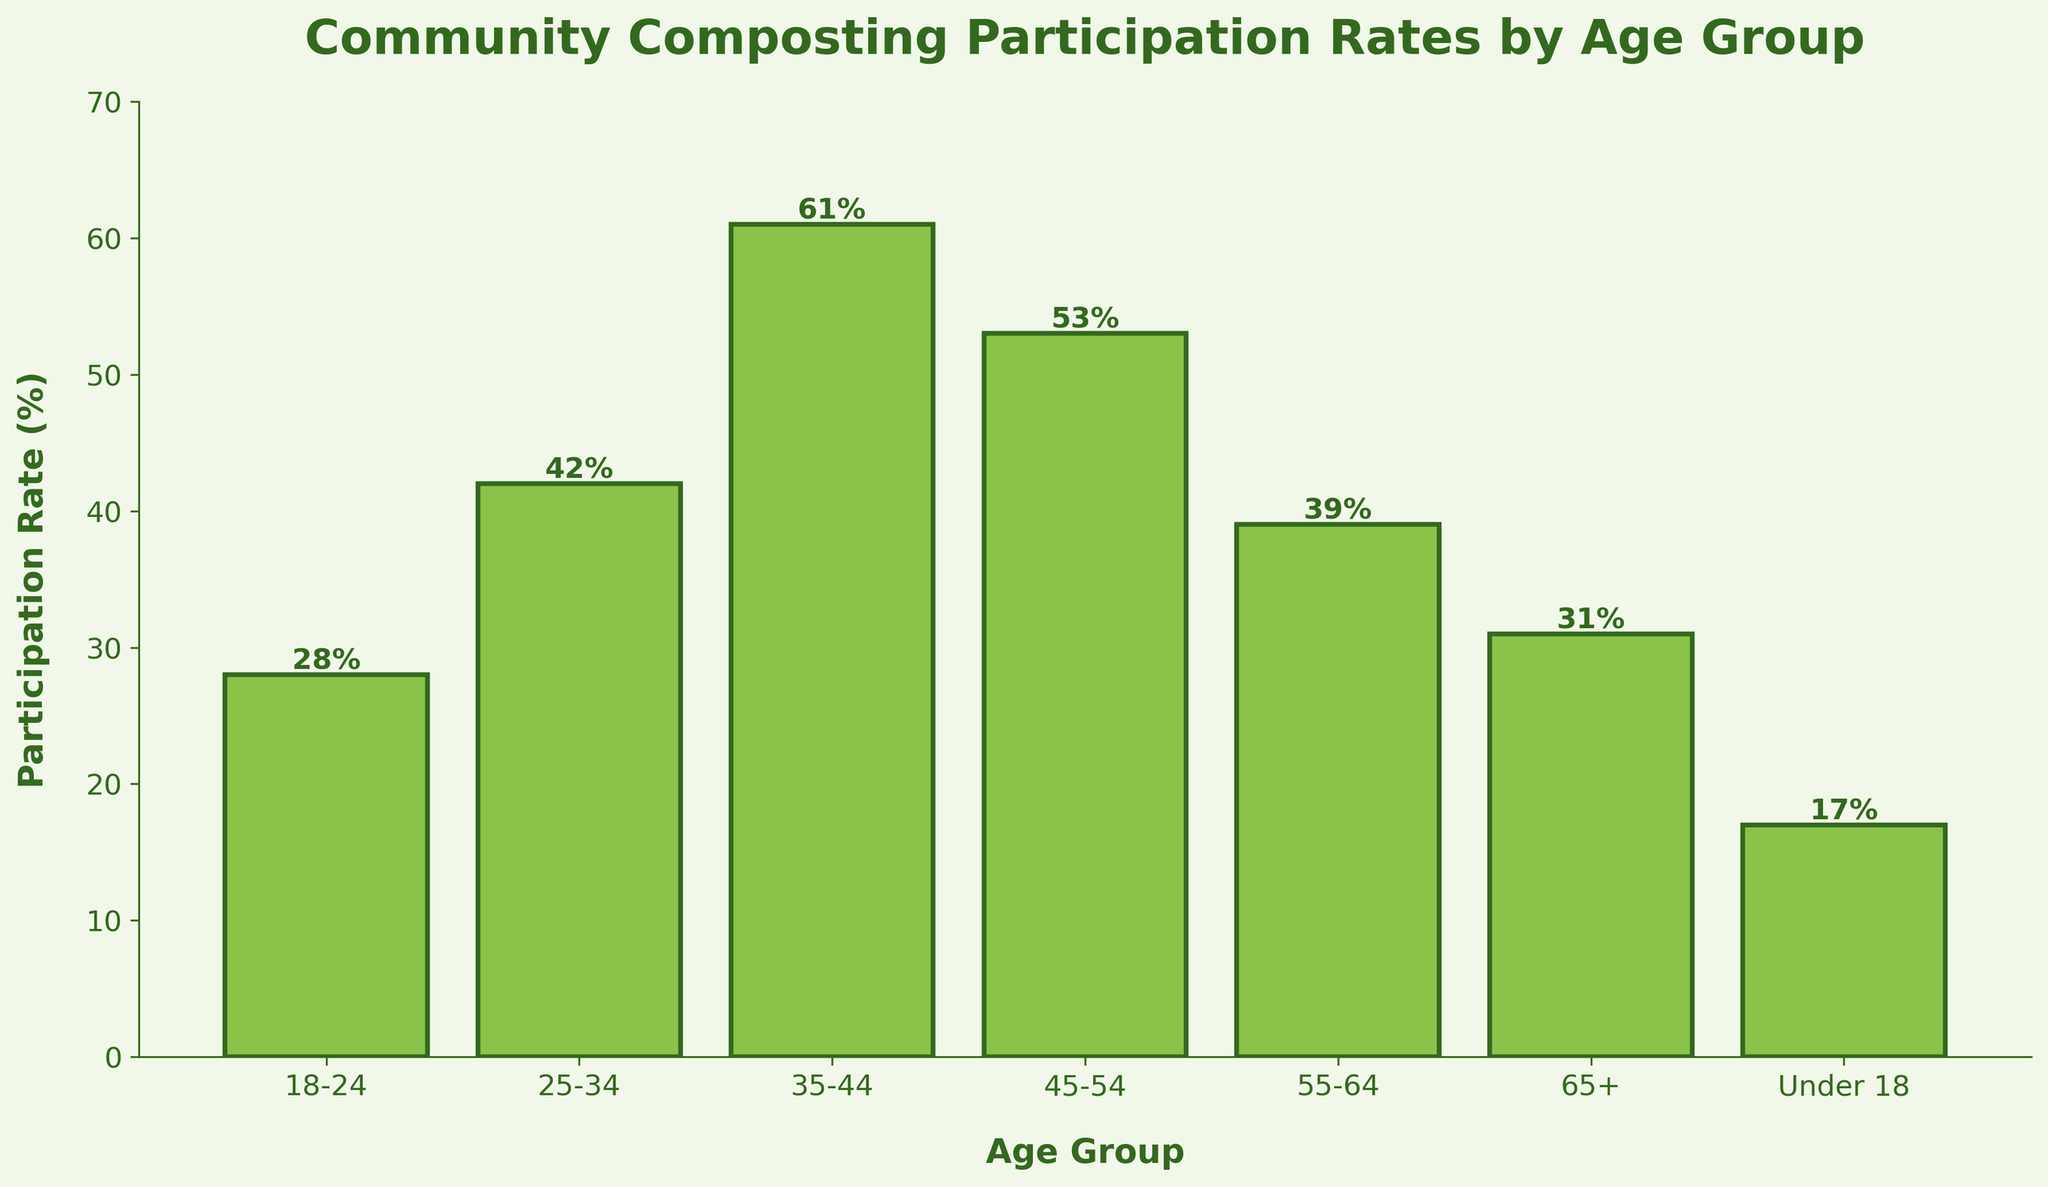What is the participation rate for the 25-34 age group? Look for the bar labeled '25-34' on the x-axis and note the height value. It corresponds to 42%.
Answer: 42% Which age group has the highest participation rate? Compare the heights of all the bars. The tallest bar is for the '35-44' age group with a participation rate of 61%.
Answer: 35-44 What is the difference in participation rates between the 45-54 age group and the 18-24 age group? Find the heights of the bars for both groups: 45-54 is 53% and 18-24 is 28%. Calculate the difference: 53% - 28% = 25%.
Answer: 25% Is the participation rate for the 55-64 age group greater than the 65+ age group? Compare the bar heights of the 55-64 and 65+ age groups. The 55-64 rate is 39%, and the 65+ rate is 31%. 39% is greater than 31%.
Answer: Yes Calculate the average participation rate across all age groups. Sum the participation rates for all age groups: 28% + 42% + 61% + 53% + 39% + 31% + 17% = 271%. Divide by the number of groups (7): 271% / 7 = 38.71%.
Answer: 38.71% Which age group has the lowest participation rate? Look for the shortest bar. The 'Under 18' age group has the lowest participation rate at 17%.
Answer: Under 18 How does the participation rate for the 18-24 group compare to the 55-64 group? Compare the bar heights: 18-24 is 28% and 55-64 is 39%. 28% is less than 39%.
Answer: Less Does the 35-44 group have more than double the participation rate of the Under 18 group? Check the participation rates: 35-44 is 61% and Under 18 is 17%. Double 17% is 34%. 61% is greater than 34%.
Answer: Yes 